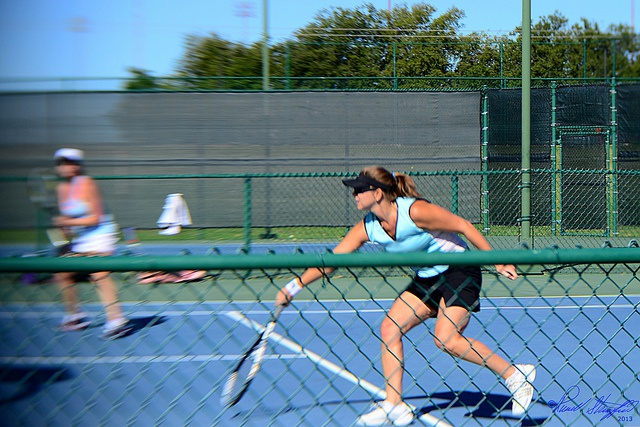Describe the objects in this image and their specific colors. I can see people in gray, black, tan, salmon, and white tones, people in gray, lightpink, and darkgray tones, tennis racket in gray, lightgray, and darkgray tones, and tennis racket in gray, purple, and black tones in this image. 